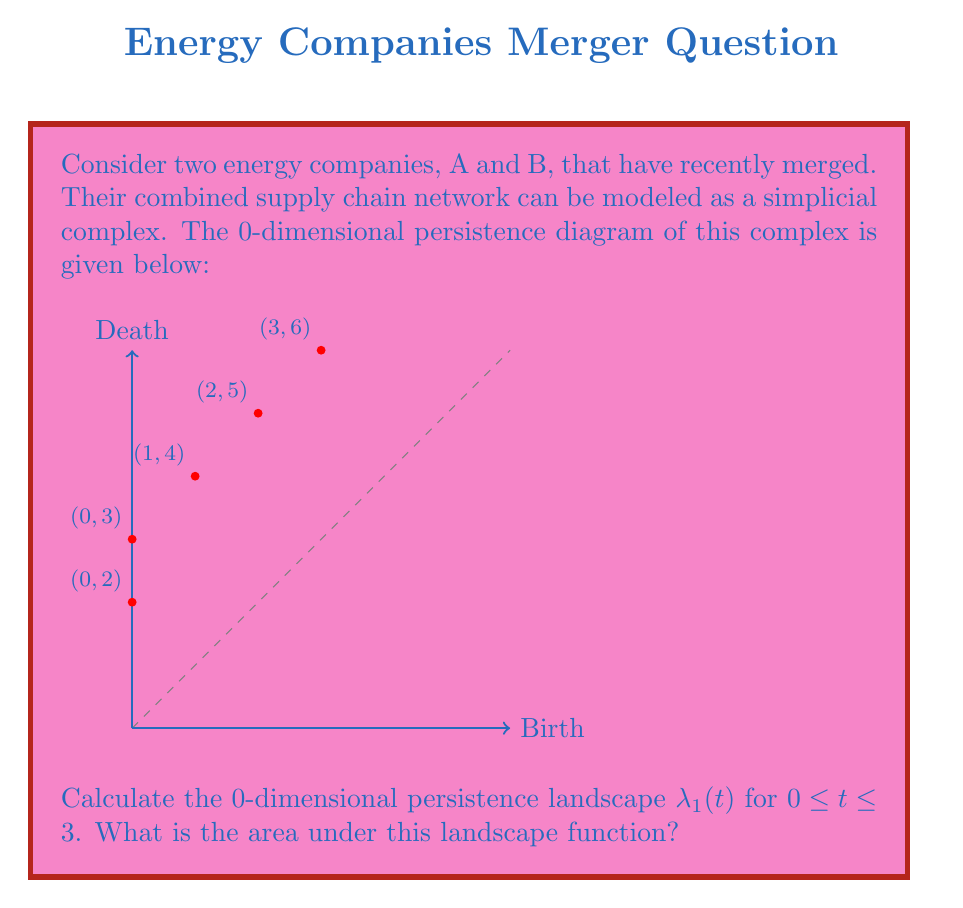Can you solve this math problem? To solve this problem, we'll follow these steps:

1) First, recall that the 0-dimensional persistence landscape is constructed from the persistence diagram by creating a series of piecewise linear functions.

2) For each point $(b_i, d_i)$ in the persistence diagram, we create a function:

   $$f_i(t) = \max(\min(t-b_i, d_i-t), 0)$$

3) The first persistence landscape function $\lambda_1(t)$ is the maximum of these functions at each point.

4) From the given persistence diagram, we have the following points:
   (0,2), (0,3), (1,4), (2,5), (3,6)

5) Let's construct the functions for each point:

   $f_1(t) = \max(\min(t-0, 2-t), 0)$
   $f_2(t) = \max(\min(t-0, 3-t), 0)$
   $f_3(t) = \max(\min(t-1, 4-t), 0)$
   $f_4(t) = \max(\min(t-2, 5-t), 0)$
   $f_5(t) = \max(\min(t-3, 6-t), 0)$

6) The landscape function $\lambda_1(t)$ is the maximum of these functions for each t.

7) Plotting these functions, we can see that $\lambda_1(t)$ consists of three line segments:
   - From t=0 to t=1, it follows $f_2(t) = t$
   - From t=1 to t=2, it follows $f_2(t) = 3-t$
   - From t=2 to t=3, it follows $f_3(t) = 4-t$

8) To find the area under $\lambda_1(t)$ from 0 to 3, we need to calculate the areas of these three triangular regions:

   Area = $\frac{1}{2} * 1 * 1 + \frac{1}{2} * 1 * 2 + \frac{1}{2} * 1 * 2$

9) Summing these areas:

   Total Area = $0.5 + 1 + 1 = 2.5$

Therefore, the area under the 0-dimensional persistence landscape $\lambda_1(t)$ for $0 \leq t \leq 3$ is 2.5.
Answer: 2.5 